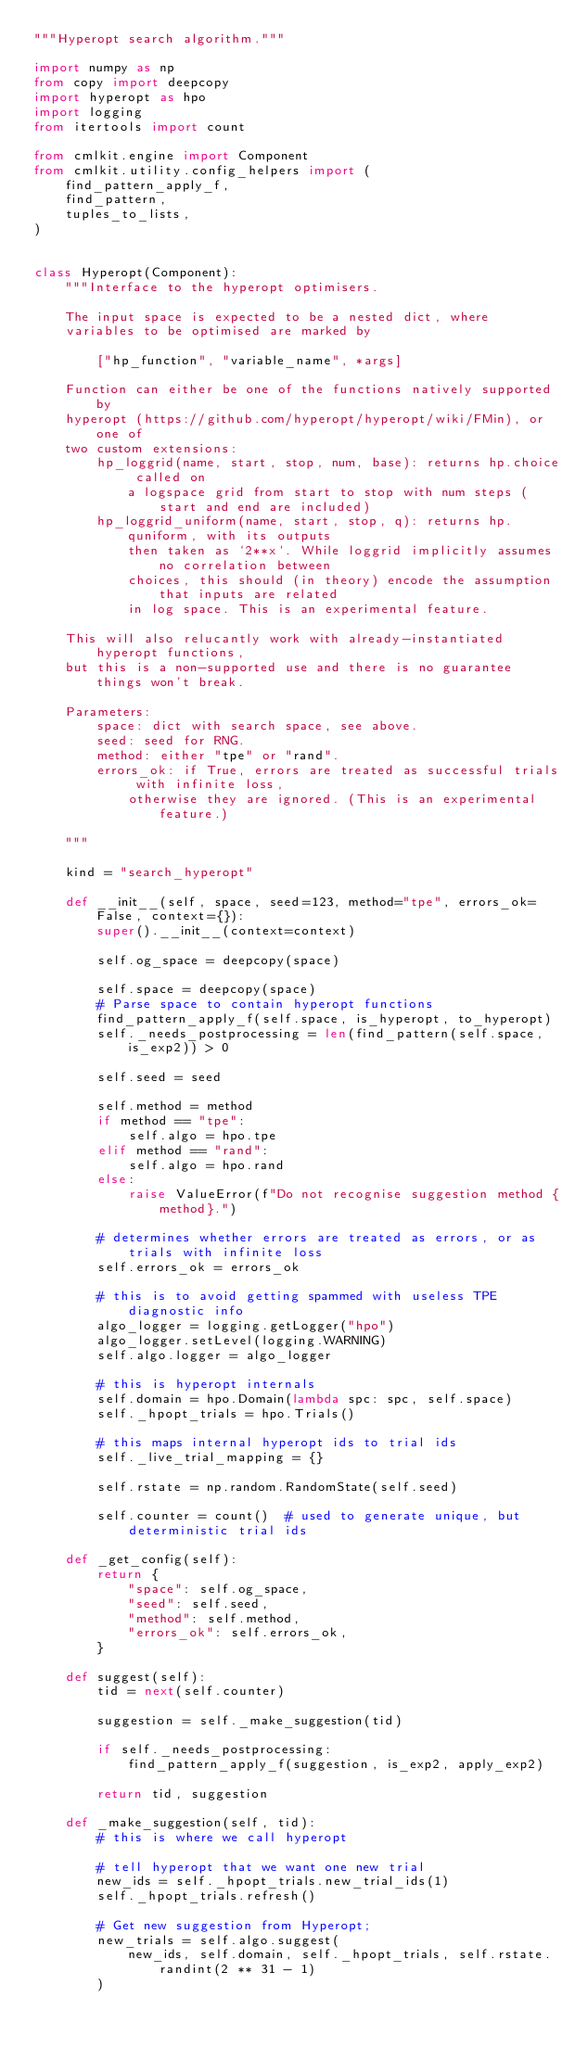<code> <loc_0><loc_0><loc_500><loc_500><_Python_>"""Hyperopt search algorithm."""

import numpy as np
from copy import deepcopy
import hyperopt as hpo
import logging
from itertools import count

from cmlkit.engine import Component
from cmlkit.utility.config_helpers import (
    find_pattern_apply_f,
    find_pattern,
    tuples_to_lists,
)


class Hyperopt(Component):
    """Interface to the hyperopt optimisers.

    The input space is expected to be a nested dict, where
    variables to be optimised are marked by

        ["hp_function", "variable_name", *args]

    Function can either be one of the functions natively supported by
    hyperopt (https://github.com/hyperopt/hyperopt/wiki/FMin), or one of
    two custom extensions:
        hp_loggrid(name, start, stop, num, base): returns hp.choice called on
            a logspace grid from start to stop with num steps (start and end are included)
        hp_loggrid_uniform(name, start, stop, q): returns hp.quniform, with its outputs
            then taken as `2**x`. While loggrid implicitly assumes no correlation between
            choices, this should (in theory) encode the assumption that inputs are related
            in log space. This is an experimental feature.

    This will also relucantly work with already-instantiated hyperopt functions,
    but this is a non-supported use and there is no guarantee things won't break.

    Parameters:
        space: dict with search space, see above.
        seed: seed for RNG.
        method: either "tpe" or "rand".
        errors_ok: if True, errors are treated as successful trials with infinite loss,
            otherwise they are ignored. (This is an experimental feature.)

    """

    kind = "search_hyperopt"

    def __init__(self, space, seed=123, method="tpe", errors_ok=False, context={}):
        super().__init__(context=context)

        self.og_space = deepcopy(space)

        self.space = deepcopy(space)
        # Parse space to contain hyperopt functions
        find_pattern_apply_f(self.space, is_hyperopt, to_hyperopt)
        self._needs_postprocessing = len(find_pattern(self.space, is_exp2)) > 0

        self.seed = seed

        self.method = method
        if method == "tpe":
            self.algo = hpo.tpe
        elif method == "rand":
            self.algo = hpo.rand
        else:
            raise ValueError(f"Do not recognise suggestion method {method}.")

        # determines whether errors are treated as errors, or as trials with infinite loss
        self.errors_ok = errors_ok

        # this is to avoid getting spammed with useless TPE diagnostic info
        algo_logger = logging.getLogger("hpo")
        algo_logger.setLevel(logging.WARNING)
        self.algo.logger = algo_logger

        # this is hyperopt internals
        self.domain = hpo.Domain(lambda spc: spc, self.space)
        self._hpopt_trials = hpo.Trials()

        # this maps internal hyperopt ids to trial ids
        self._live_trial_mapping = {}

        self.rstate = np.random.RandomState(self.seed)

        self.counter = count()  # used to generate unique, but deterministic trial ids

    def _get_config(self):
        return {
            "space": self.og_space,
            "seed": self.seed,
            "method": self.method,
            "errors_ok": self.errors_ok,
        }

    def suggest(self):
        tid = next(self.counter)

        suggestion = self._make_suggestion(tid)

        if self._needs_postprocessing:
            find_pattern_apply_f(suggestion, is_exp2, apply_exp2)

        return tid, suggestion

    def _make_suggestion(self, tid):
        # this is where we call hyperopt

        # tell hyperopt that we want one new trial
        new_ids = self._hpopt_trials.new_trial_ids(1)
        self._hpopt_trials.refresh()

        # Get new suggestion from Hyperopt;
        new_trials = self.algo.suggest(
            new_ids, self.domain, self._hpopt_trials, self.rstate.randint(2 ** 31 - 1)
        )</code> 